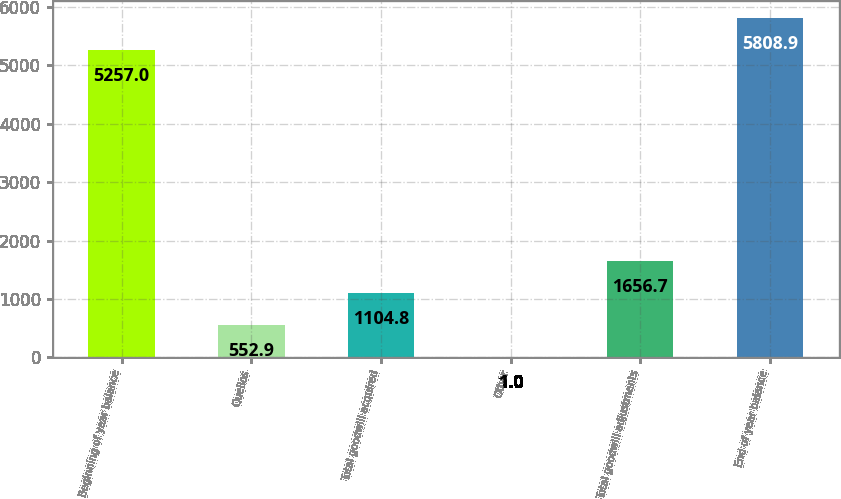<chart> <loc_0><loc_0><loc_500><loc_500><bar_chart><fcel>Beginning of year balance<fcel>Quellos<fcel>Total goodwill acquired<fcel>Other<fcel>Total goodwill adjustments<fcel>End of year balance<nl><fcel>5257<fcel>552.9<fcel>1104.8<fcel>1<fcel>1656.7<fcel>5808.9<nl></chart> 